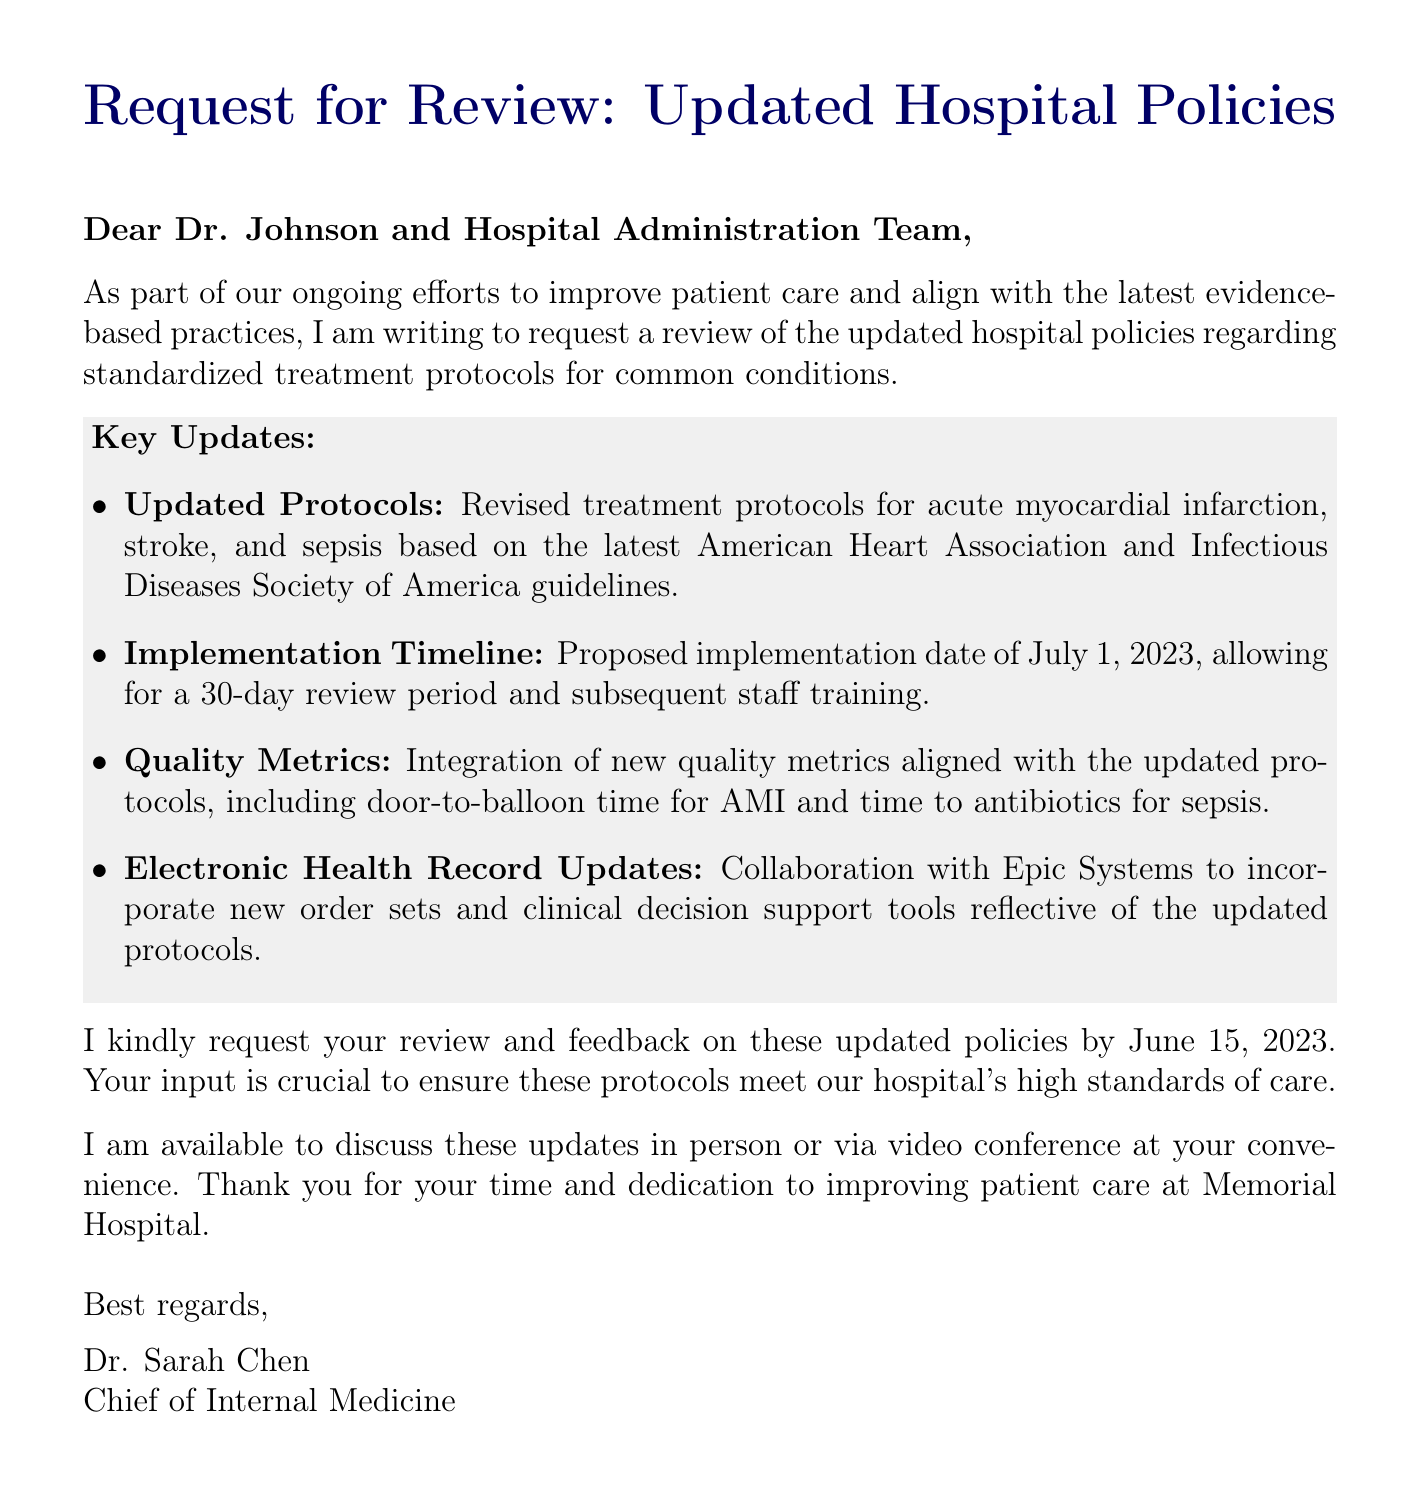What is the purpose of the email? The purpose of the email is to request a review of the updated hospital policies regarding standardized treatment protocols for common conditions.
Answer: Request a review of the updated hospital policies Who is the sender of the email? The sender is identified at the end of the email as Dr. Sarah Chen.
Answer: Dr. Sarah Chen What is the proposed implementation date of the updated protocols? The proposed implementation date mentioned is July 1, 2023.
Answer: July 1, 2023 Which guidelines are the updated treatment protocols based on? The updated treatment protocols are based on the latest American Heart Association and Infectious Diseases Society of America guidelines.
Answer: American Heart Association and Infectious Diseases Society of America guidelines What is the deadline for the review feedback? The deadline for the review feedback is June 15, 2023.
Answer: June 15, 2023 What type of support tools are being incorporated into the Electronic Health Record updates? New order sets and clinical decision support tools are being incorporated.
Answer: New order sets and clinical decision support tools What quality metrics are mentioned in the document? The quality metrics include door-to-balloon time for AMI and time to antibiotics for sepsis.
Answer: Door-to-balloon time for AMI and time to antibiotics for sepsis What does the author express gratitude for? The author expresses gratitude for the time and dedication to improving patient care at Memorial Hospital.
Answer: Time and dedication to improving patient care at Memorial Hospital 